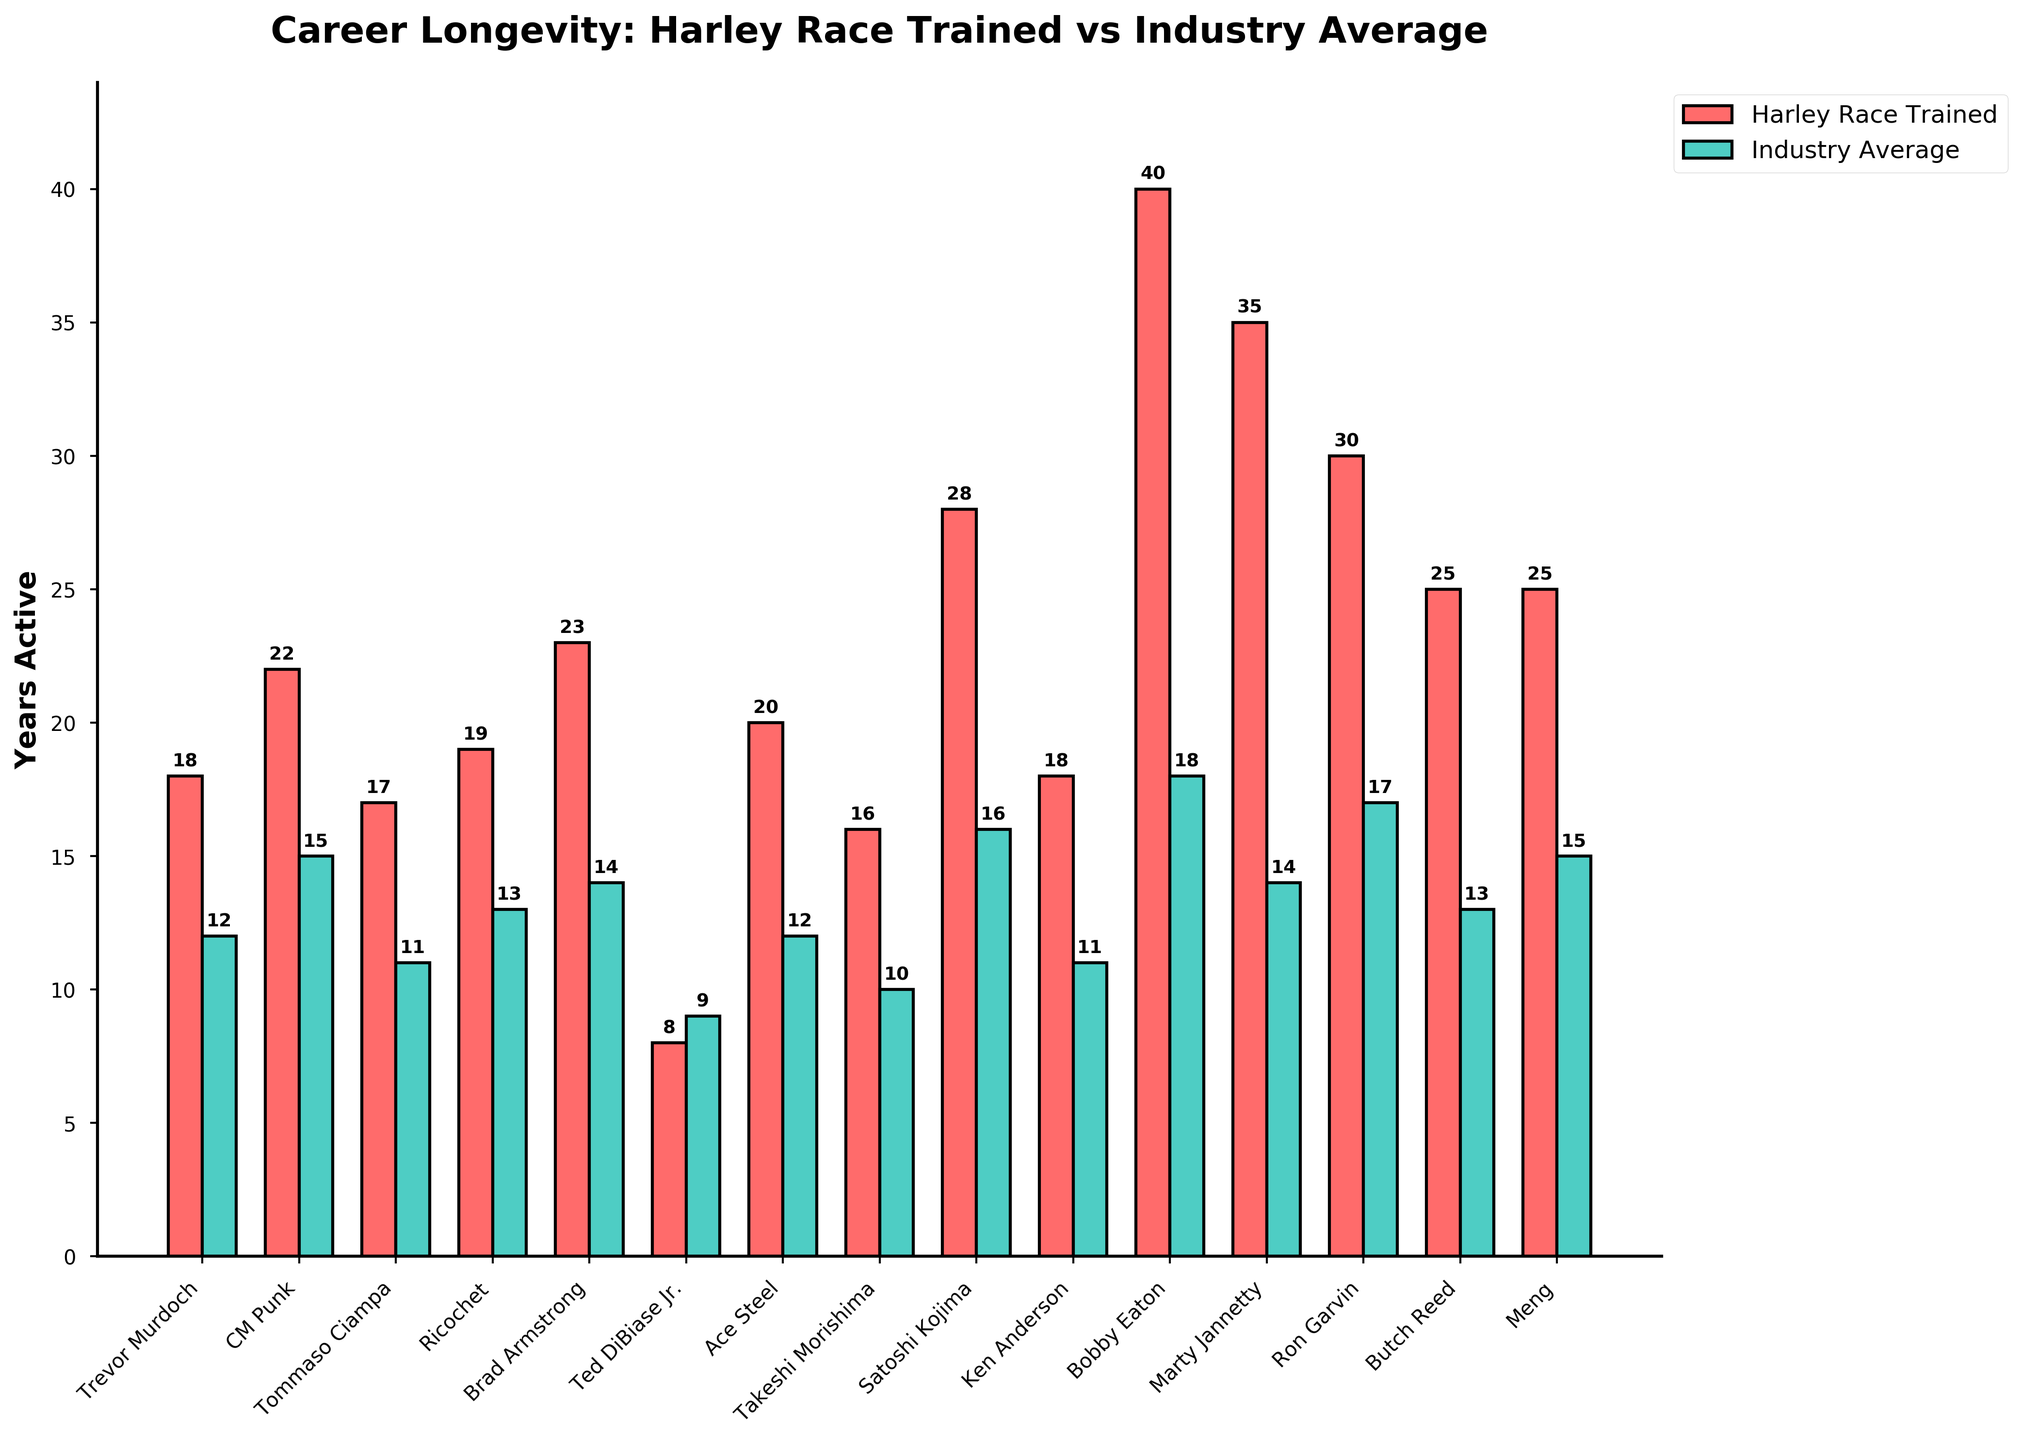Which wrestler trained by Harley Race has the longest career? Bobby Eaton is the tallest bar in the Harley Race Trained group, indicating the longest career duration.
Answer: Bobby Eaton Which has a higher average career duration, Harley Race Trained wrestlers or Industry Average? Summing the Harley Race Trained values (340) and dividing by the number of wrestlers (15) gives 22.67 years. For Industry Average, summing the values (200) and dividing by the number of wrestlers (15) gives 13.33 years.
Answer: Harley Race Trained Who has the shortest career among the Harley Race Trained wrestlers? Ted DiBiase Jr. has the shortest bar in the Harley Race Trained group, indicating the shortest career duration.
Answer: Ted DiBiase Jr Which wrestler has the largest difference in years active between Harley Race Trained and Industry Average? Subtracting the Industry Average from Harley Race Trained for each wrestler and finding the maximum difference: Bobby Eaton (40-18=22) has the largest difference.
Answer: Bobby Eaton How does Ron Garvin's career compare between Harley Race Trained and Industry Average? Ron Garvin's bar in Harley Race's group is 30 years, while the bar in Industry Average is 17 years.
Answer: Longer in Harley Race Is there any wrestler whose industry average career duration is longer than their career trained by Harley Race? Ted DiBiase Jr.'s Industry Average (9 years) is higher than his Harley Race Trained (8 years).
Answer: Ted DiBiase Jr What's the combined total of years active for wrestlers trained by Harley Race? Summing the Harley Race Trained durations: 18 + 22 + 17 + 19 + 23 + 8 + 20 + 16 + 28 + 18 + 40 + 35 + 30 + 25 + 25 = 340 years.
Answer: 340 years Who has the most significant difference in career duration between Harley Race Trained and Industry Average? Calculating difference for each wrestler: Bobby Eaton's difference is 22 years, the highest.
Answer: Bobby Eaton How many wrestlers have a career longevity of 20 or more years trained by Harley Race? Count the bars in the Harley Race group that are 20 or higher: CM Punk, Ace Steel, Satoshi Kojima, Bobby Eaton, Marty Jannetty, Ron Garvin, Butch Reed, Meng = 8 wrestlers.
Answer: 8 wrestlers 